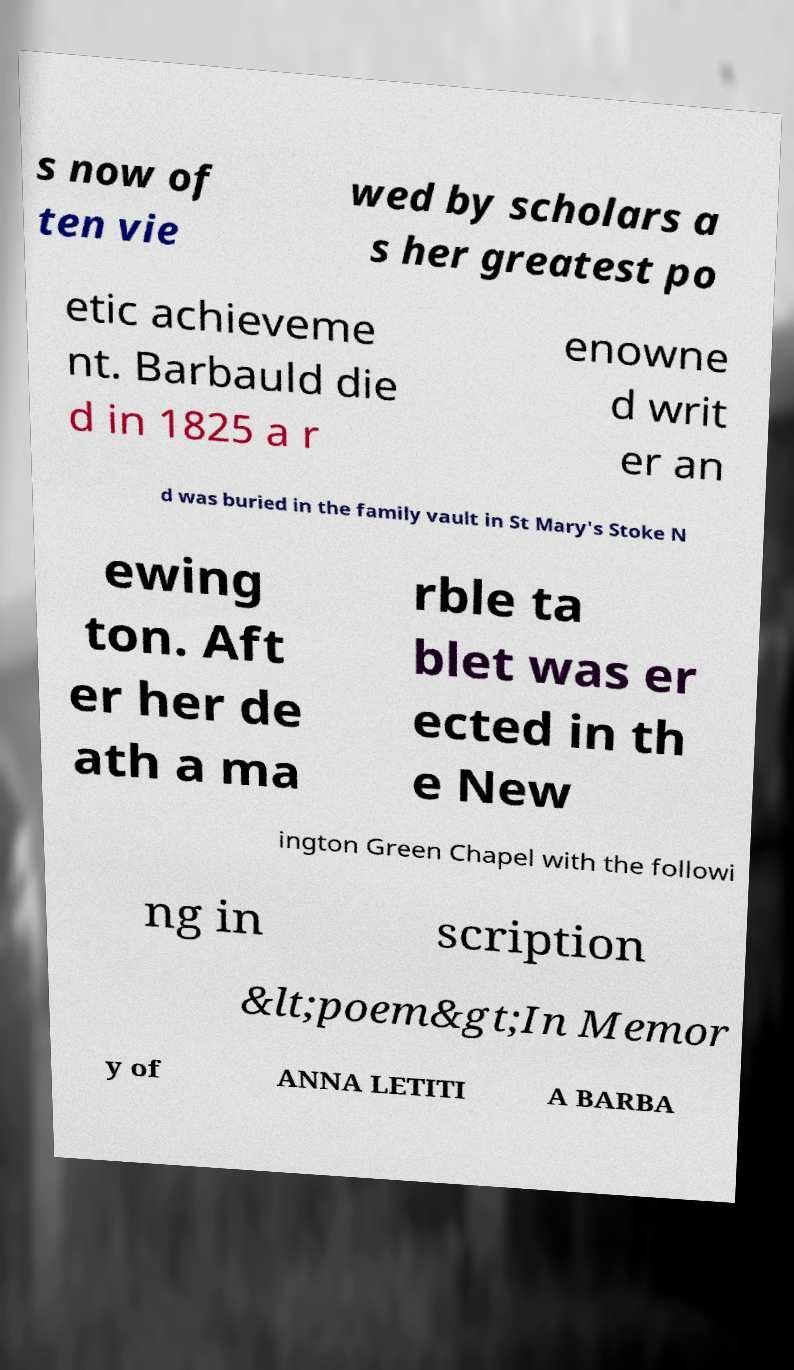Can you accurately transcribe the text from the provided image for me? s now of ten vie wed by scholars a s her greatest po etic achieveme nt. Barbauld die d in 1825 a r enowne d writ er an d was buried in the family vault in St Mary's Stoke N ewing ton. Aft er her de ath a ma rble ta blet was er ected in th e New ington Green Chapel with the followi ng in scription &lt;poem&gt;In Memor y of ANNA LETITI A BARBA 